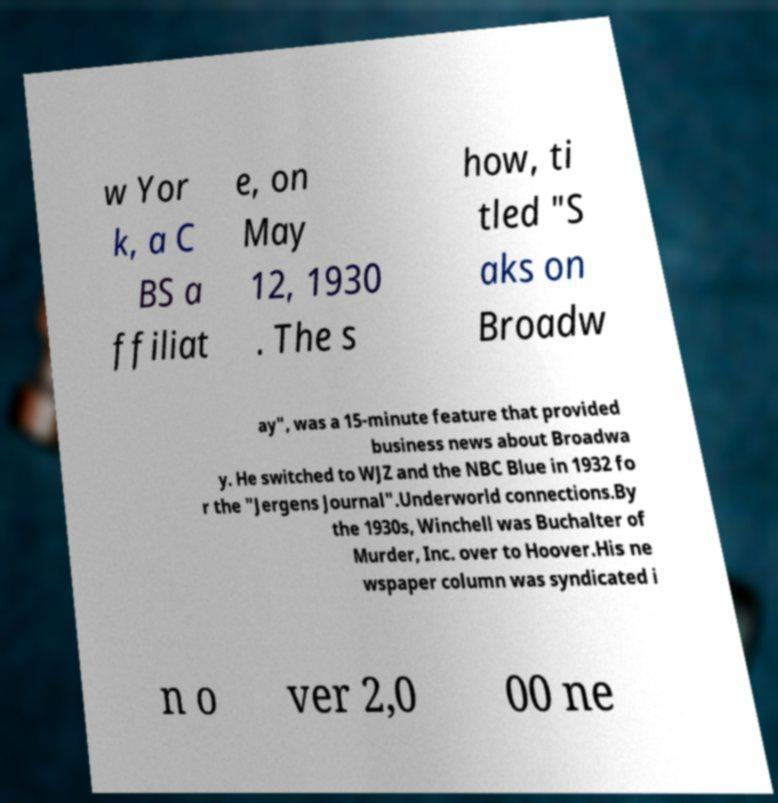For documentation purposes, I need the text within this image transcribed. Could you provide that? w Yor k, a C BS a ffiliat e, on May 12, 1930 . The s how, ti tled "S aks on Broadw ay", was a 15-minute feature that provided business news about Broadwa y. He switched to WJZ and the NBC Blue in 1932 fo r the "Jergens Journal".Underworld connections.By the 1930s, Winchell was Buchalter of Murder, Inc. over to Hoover.His ne wspaper column was syndicated i n o ver 2,0 00 ne 